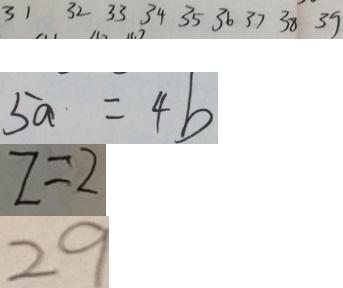Convert formula to latex. <formula><loc_0><loc_0><loc_500><loc_500>3 1 3 2 3 3 3 4 3 5 3 6 3 7 3 8 3 9 
 5 a \cdot = 4 b 
 z = 2 
 2 9</formula> 